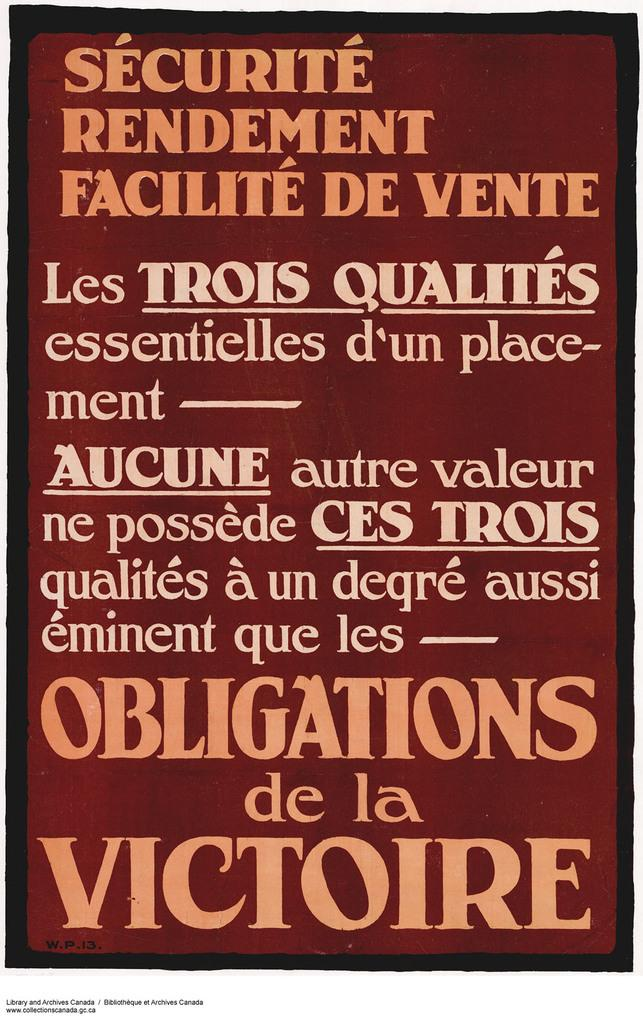Provide a one-sentence caption for the provided image. A sign written out in french, with big letters saying Obligations de la Victoire. 